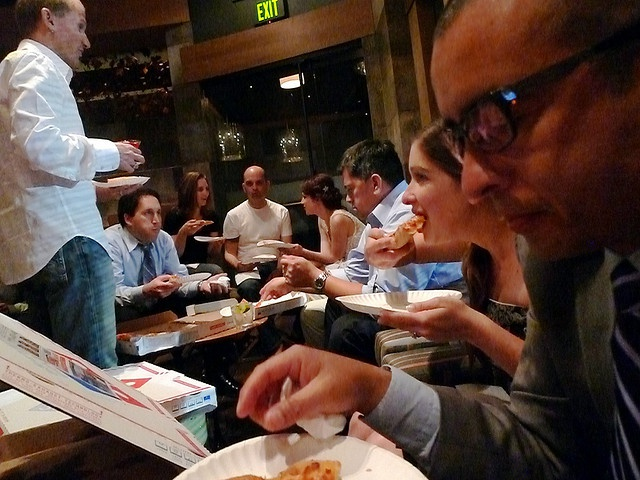Describe the objects in this image and their specific colors. I can see people in black, maroon, brown, and gray tones, people in black, darkgray, and gray tones, people in black, maroon, and brown tones, people in black, maroon, lightgray, and darkgray tones, and people in black, darkgray, maroon, and gray tones in this image. 